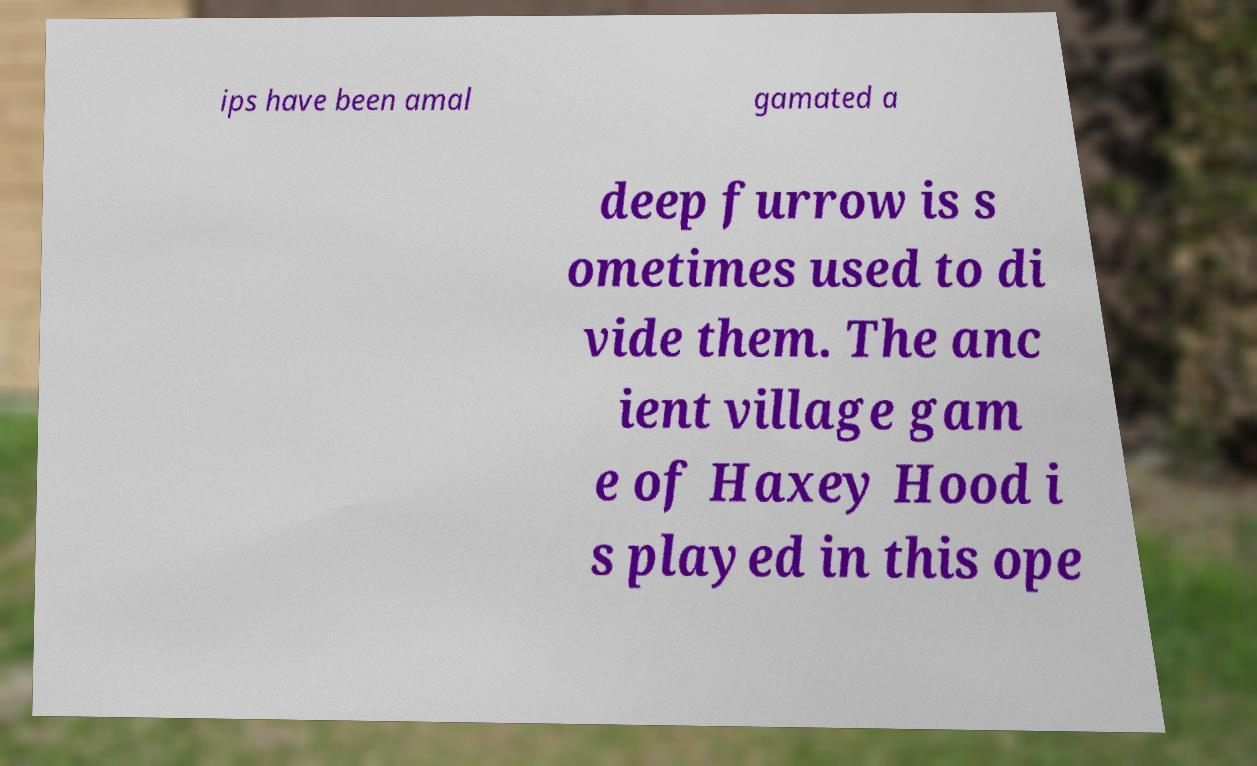There's text embedded in this image that I need extracted. Can you transcribe it verbatim? ips have been amal gamated a deep furrow is s ometimes used to di vide them. The anc ient village gam e of Haxey Hood i s played in this ope 